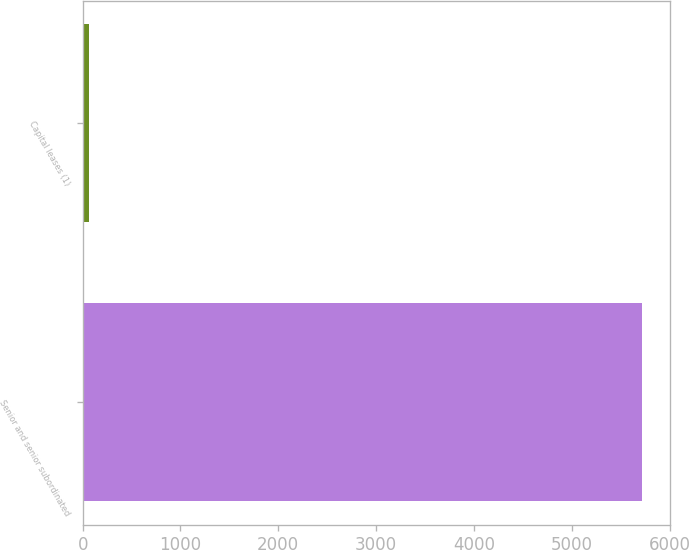<chart> <loc_0><loc_0><loc_500><loc_500><bar_chart><fcel>Senior and senior subordinated<fcel>Capital leases (1)<nl><fcel>5715<fcel>70<nl></chart> 